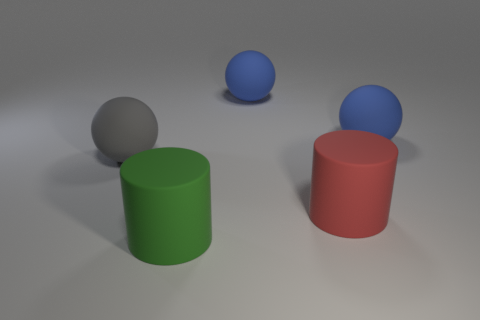Are there fewer large blue spheres that are in front of the big green matte thing than big green shiny spheres?
Ensure brevity in your answer.  No. What is the shape of the gray thing that is the same size as the red rubber object?
Give a very brief answer. Sphere. Does the gray ball have the same size as the red cylinder?
Give a very brief answer. Yes. How many objects are either green cylinders or matte objects that are on the right side of the big gray matte object?
Offer a terse response. 4. Is the number of large rubber cylinders right of the red thing less than the number of large matte things in front of the big gray object?
Offer a terse response. Yes. What number of other objects are there of the same material as the large green cylinder?
Keep it short and to the point. 4. Is there a big ball in front of the red cylinder right of the green rubber object?
Provide a short and direct response. No. What is the material of the big sphere that is both on the left side of the large red cylinder and on the right side of the gray matte sphere?
Keep it short and to the point. Rubber. What shape is the big red thing that is made of the same material as the gray object?
Your response must be concise. Cylinder. Are there any other things that are the same shape as the green matte object?
Offer a very short reply. Yes. 